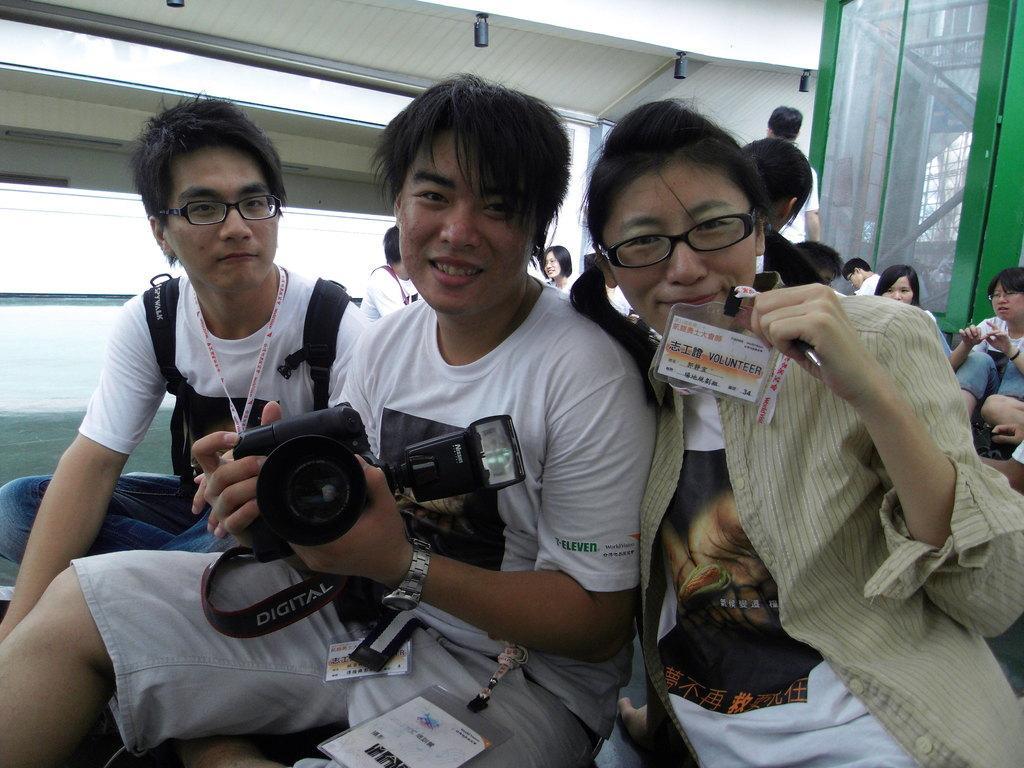How would you summarize this image in a sentence or two? Here we can see two men and a woman are sitting on a platform and the middle person is holding a camera in his hands and we can see ID cards and the left side man is carrying a bag on his shoulders. In the background there are few persons sitting and a person is standing and there is a glass door,lights on the roof. Through the glass door we can see poles,pipes and metal objects. 